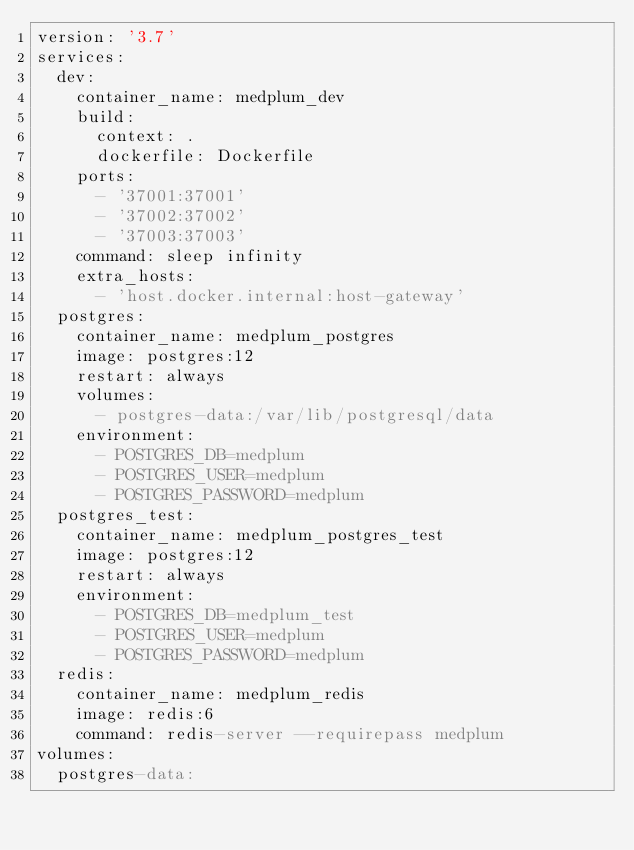Convert code to text. <code><loc_0><loc_0><loc_500><loc_500><_YAML_>version: '3.7'
services:
  dev:
    container_name: medplum_dev
    build:
      context: .
      dockerfile: Dockerfile
    ports:
      - '37001:37001'
      - '37002:37002'
      - '37003:37003'
    command: sleep infinity
    extra_hosts:
      - 'host.docker.internal:host-gateway'
  postgres:
    container_name: medplum_postgres
    image: postgres:12
    restart: always
    volumes:
      - postgres-data:/var/lib/postgresql/data
    environment:
      - POSTGRES_DB=medplum
      - POSTGRES_USER=medplum
      - POSTGRES_PASSWORD=medplum
  postgres_test:
    container_name: medplum_postgres_test
    image: postgres:12
    restart: always
    environment:
      - POSTGRES_DB=medplum_test
      - POSTGRES_USER=medplum
      - POSTGRES_PASSWORD=medplum
  redis:
    container_name: medplum_redis
    image: redis:6
    command: redis-server --requirepass medplum
volumes:
  postgres-data:
</code> 